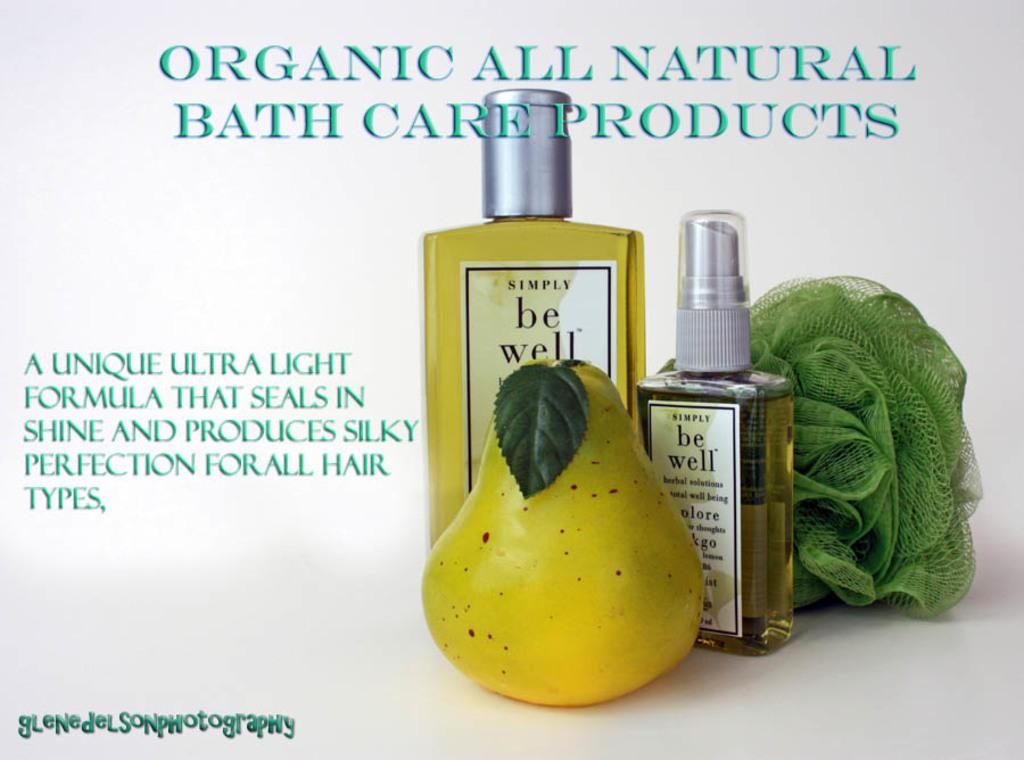Provide a one-sentence caption for the provided image. an ad for Organic All Natural Bath Care Products. 